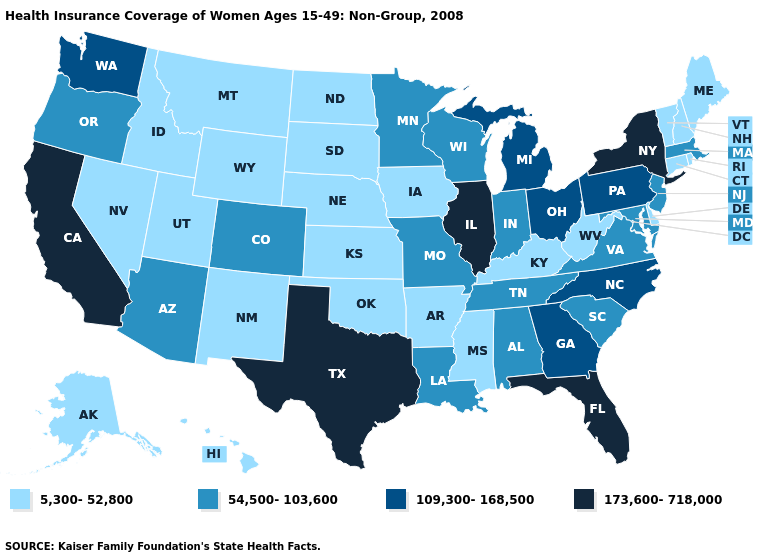What is the value of Texas?
Quick response, please. 173,600-718,000. What is the lowest value in the USA?
Concise answer only. 5,300-52,800. What is the value of Wyoming?
Be succinct. 5,300-52,800. Does the map have missing data?
Answer briefly. No. What is the lowest value in the USA?
Quick response, please. 5,300-52,800. What is the highest value in the MidWest ?
Write a very short answer. 173,600-718,000. What is the value of South Carolina?
Write a very short answer. 54,500-103,600. What is the value of Alaska?
Concise answer only. 5,300-52,800. What is the value of North Dakota?
Short answer required. 5,300-52,800. Among the states that border Ohio , does Pennsylvania have the highest value?
Give a very brief answer. Yes. Name the states that have a value in the range 54,500-103,600?
Concise answer only. Alabama, Arizona, Colorado, Indiana, Louisiana, Maryland, Massachusetts, Minnesota, Missouri, New Jersey, Oregon, South Carolina, Tennessee, Virginia, Wisconsin. Does Missouri have a lower value than Wisconsin?
Answer briefly. No. Does the map have missing data?
Keep it brief. No. What is the highest value in the MidWest ?
Answer briefly. 173,600-718,000. Among the states that border Wyoming , which have the highest value?
Keep it brief. Colorado. 